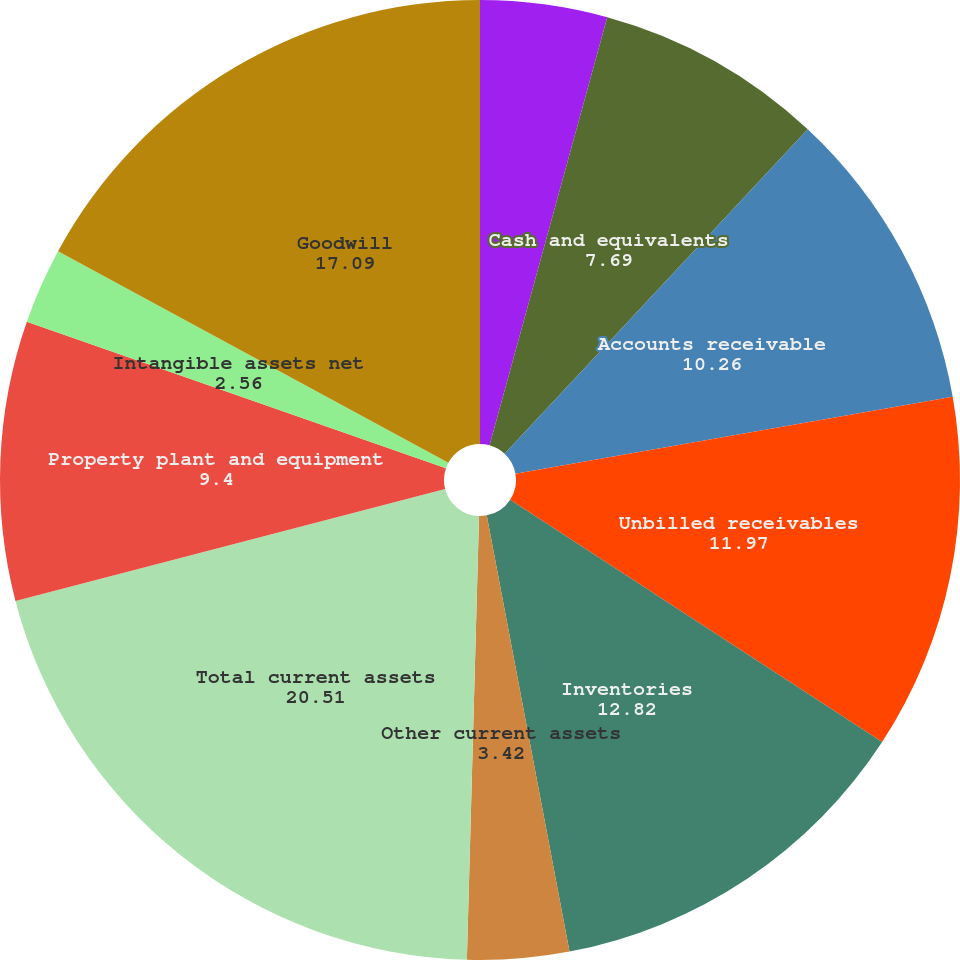<chart> <loc_0><loc_0><loc_500><loc_500><pie_chart><fcel>(Dollars in millions)<fcel>Cash and equivalents<fcel>Accounts receivable<fcel>Unbilled receivables<fcel>Inventories<fcel>Other current assets<fcel>Total current assets<fcel>Property plant and equipment<fcel>Intangible assets net<fcel>Goodwill<nl><fcel>4.27%<fcel>7.69%<fcel>10.26%<fcel>11.97%<fcel>12.82%<fcel>3.42%<fcel>20.51%<fcel>9.4%<fcel>2.56%<fcel>17.09%<nl></chart> 